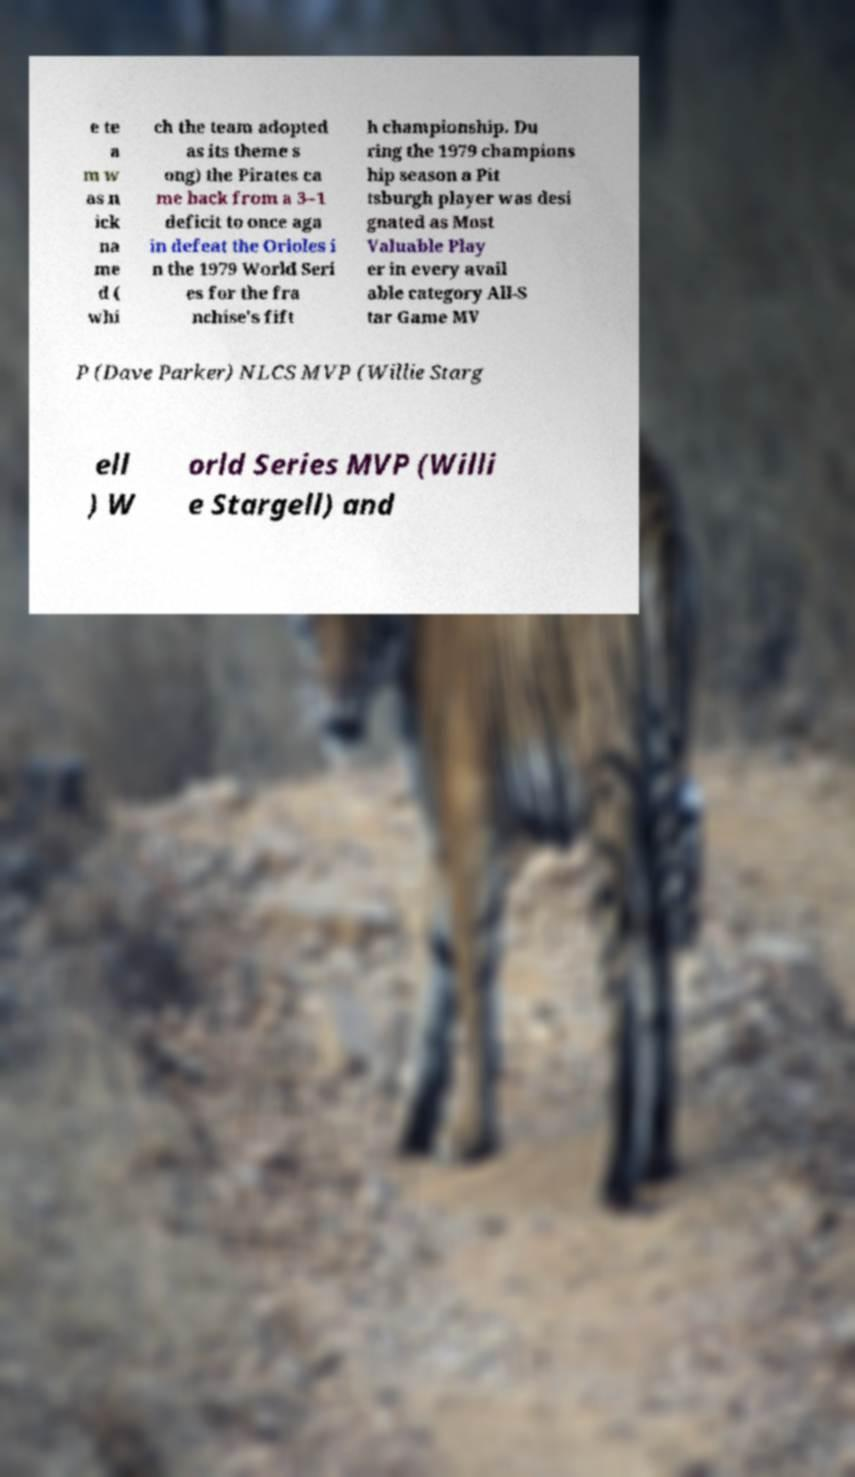For documentation purposes, I need the text within this image transcribed. Could you provide that? e te a m w as n ick na me d ( whi ch the team adopted as its theme s ong) the Pirates ca me back from a 3–1 deficit to once aga in defeat the Orioles i n the 1979 World Seri es for the fra nchise's fift h championship. Du ring the 1979 champions hip season a Pit tsburgh player was desi gnated as Most Valuable Play er in every avail able category All-S tar Game MV P (Dave Parker) NLCS MVP (Willie Starg ell ) W orld Series MVP (Willi e Stargell) and 